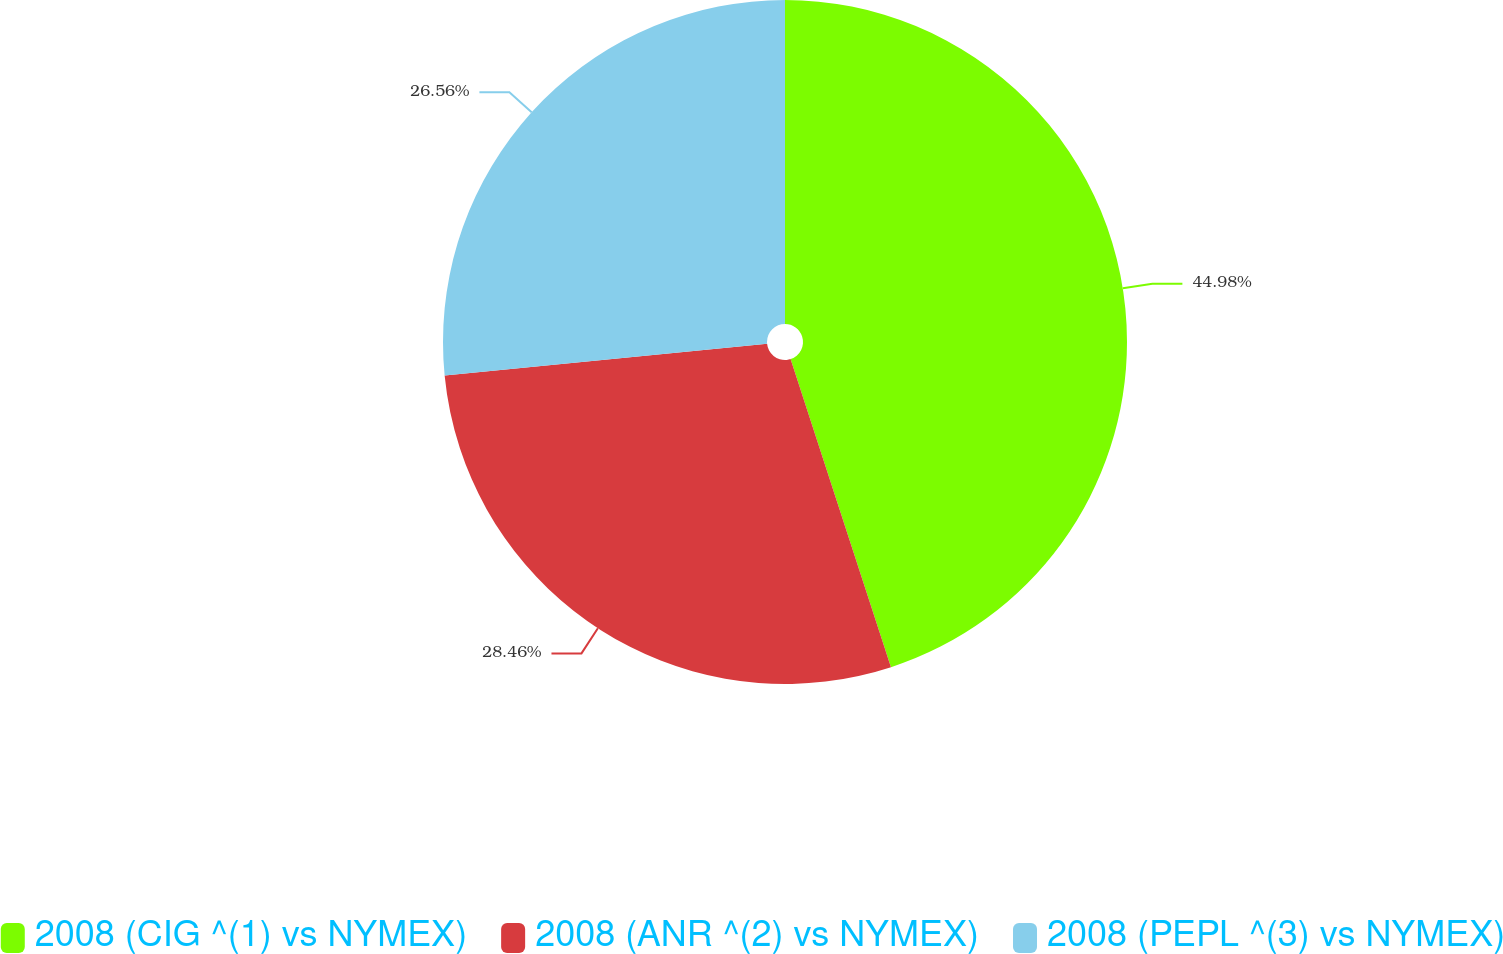Convert chart. <chart><loc_0><loc_0><loc_500><loc_500><pie_chart><fcel>2008 (CIG ^(1) vs NYMEX)<fcel>2008 (ANR ^(2) vs NYMEX)<fcel>2008 (PEPL ^(3) vs NYMEX)<nl><fcel>44.99%<fcel>28.46%<fcel>26.56%<nl></chart> 